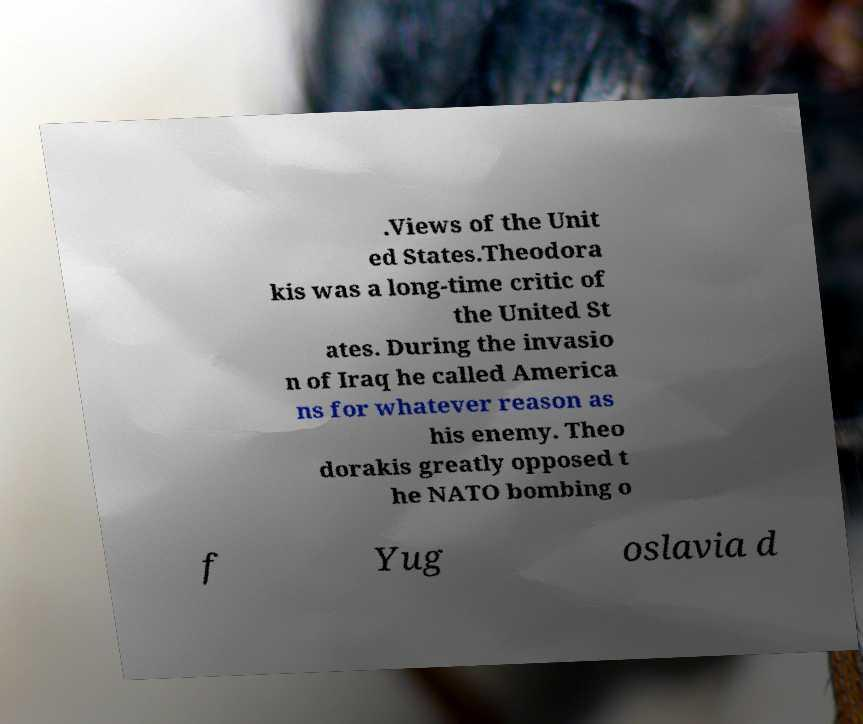Could you extract and type out the text from this image? .Views of the Unit ed States.Theodora kis was a long-time critic of the United St ates. During the invasio n of Iraq he called America ns for whatever reason as his enemy. Theo dorakis greatly opposed t he NATO bombing o f Yug oslavia d 